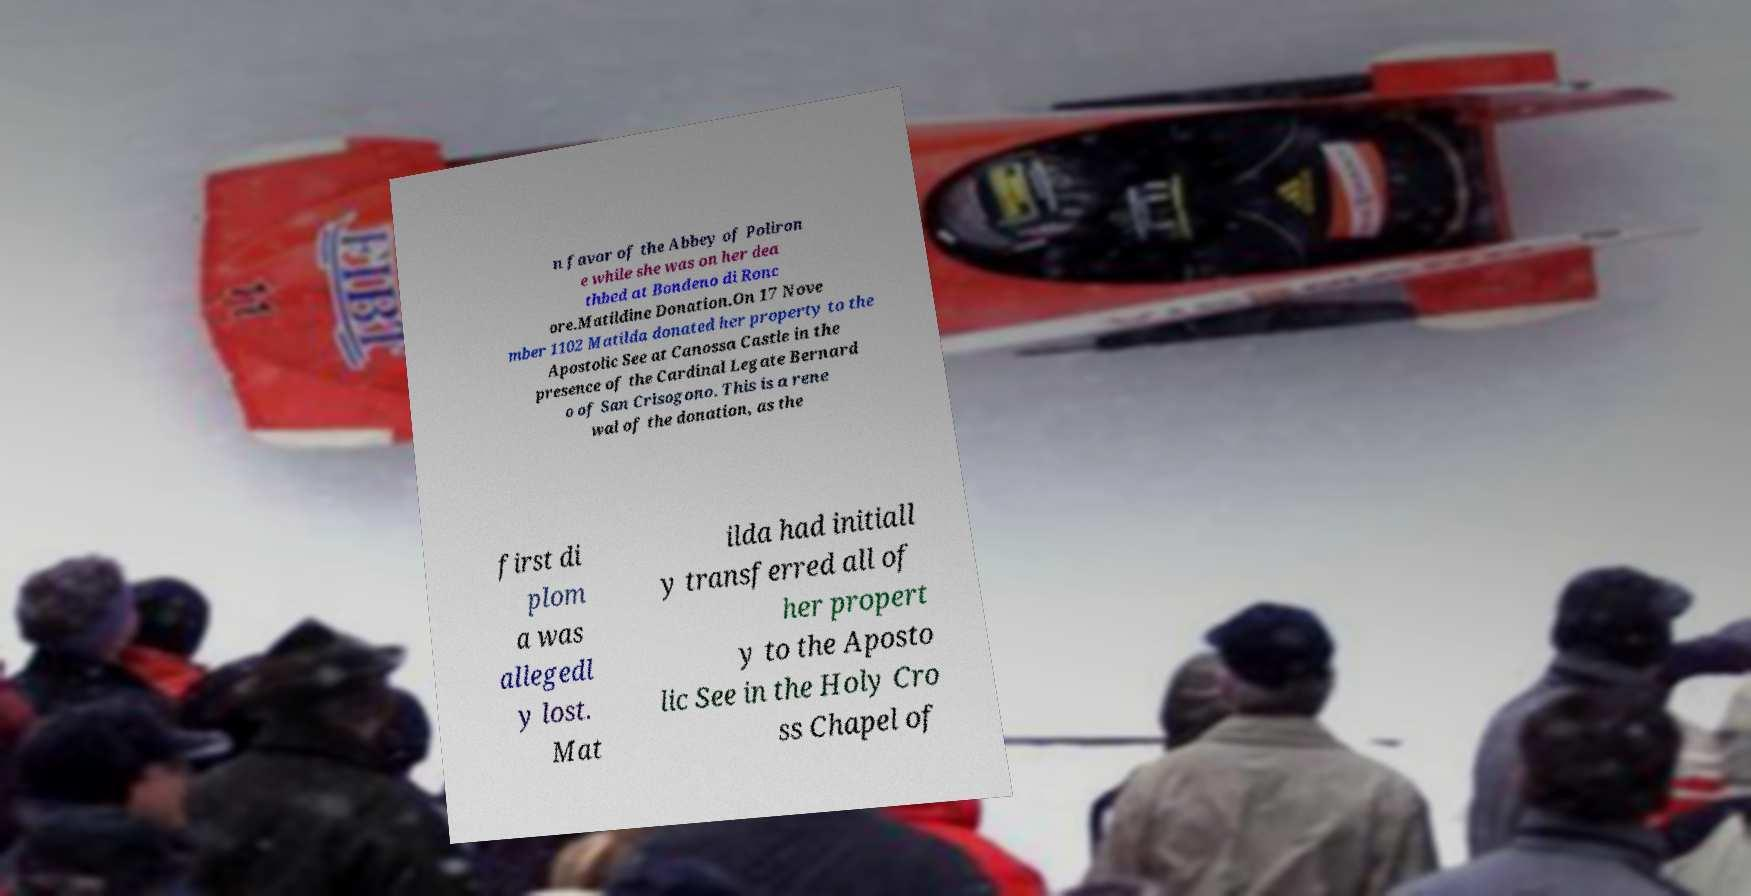What messages or text are displayed in this image? I need them in a readable, typed format. n favor of the Abbey of Poliron e while she was on her dea thbed at Bondeno di Ronc ore.Matildine Donation.On 17 Nove mber 1102 Matilda donated her property to the Apostolic See at Canossa Castle in the presence of the Cardinal Legate Bernard o of San Crisogono. This is a rene wal of the donation, as the first di plom a was allegedl y lost. Mat ilda had initiall y transferred all of her propert y to the Aposto lic See in the Holy Cro ss Chapel of 